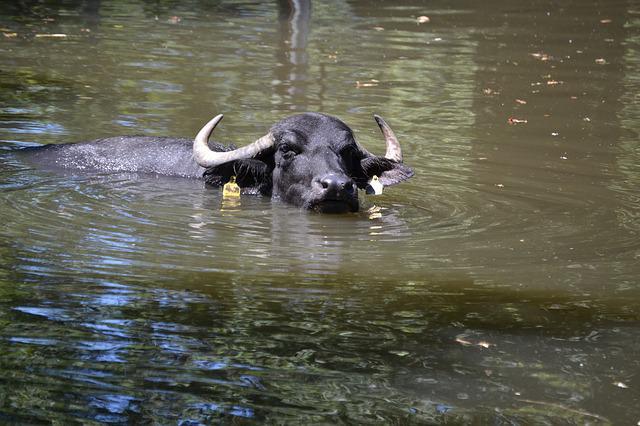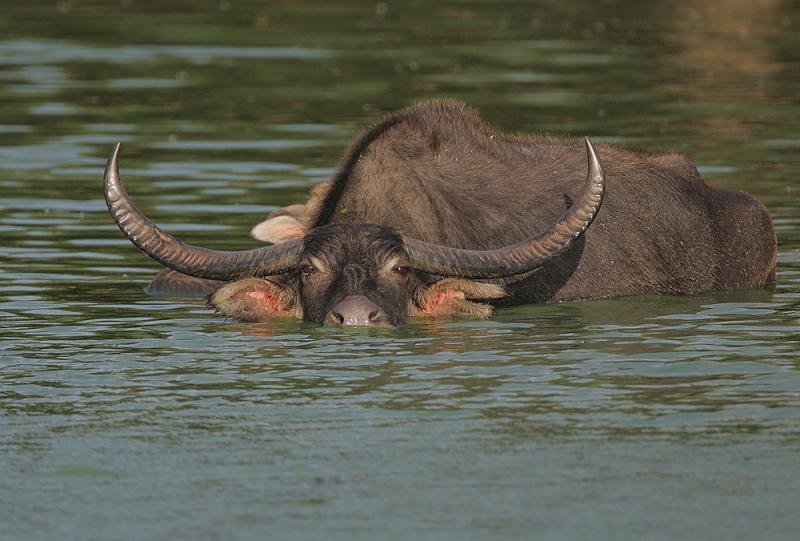The first image is the image on the left, the second image is the image on the right. Given the left and right images, does the statement "A water buffalo is walking through water in one image." hold true? Answer yes or no. Yes. 